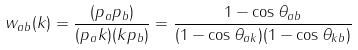<formula> <loc_0><loc_0><loc_500><loc_500>w _ { a b } ( k ) = \frac { ( p _ { a } p _ { b } ) } { ( p _ { a } k ) ( k p _ { b } ) } = \frac { 1 - \cos \theta _ { a b } } { ( 1 - \cos \theta _ { a k } ) ( 1 - \cos \theta _ { k b } ) }</formula> 